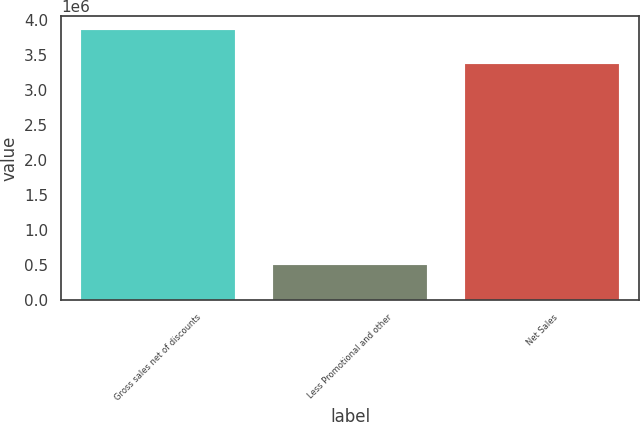<chart> <loc_0><loc_0><loc_500><loc_500><bar_chart><fcel>Gross sales net of discounts<fcel>Less Promotional and other<fcel>Net Sales<nl><fcel>3.86137e+06<fcel>492323<fcel>3.36904e+06<nl></chart> 